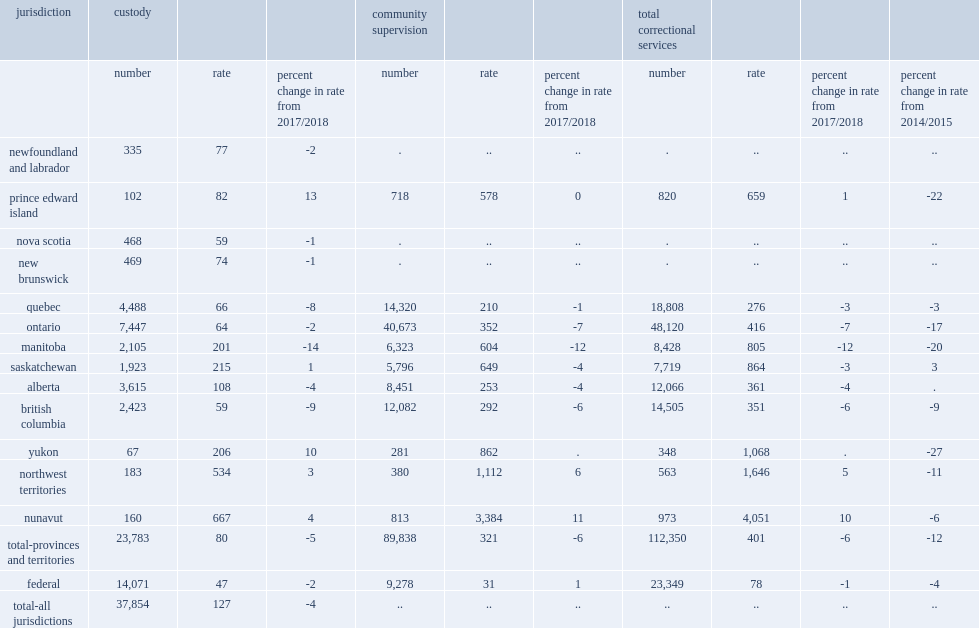In 2018/2019, what is the rate of custody of the national incarceration population? 127.0. In 2018/2019, the national incarceration rate of custody was 127 adults per 100,000 population, how much percentage below the rate from the previous year? 4. How many adults of average in provincial/territorial and federal custody per day in 2018/2019? 37854.0. How many adults were in provincial/territorial custody in 2018/2019? 23783.0. What is the rate of adults were in provincial/territorial custody in 2018/2019? 80.0. How many adults were in federal custody in 2018/2019? 14071.0. What is the rate of adults were in federal custody in 2018/2019? 47.0. Meanwhile, how much rates increased in prince edward island in 2018/2019? 13.0. Meanwhile, how much rates increased in yukon in 2018/2019? 10.0. Meanwhile, how much rates increased in nunavut in 2018/2019? 4.0. Meanwhile, how much rates increased in northwest territories in 2018/2019? 3.0. Meanwhile, how much rates increased in saskatchewan in 2018/2019? 1.0. In 2018/2019,what is the rate of adult provincial/territorial incarceration in saskatchewan ? 215.0. In 2018/2019,what is the rate of adult provincial/territorial incarceration in manitoba ? 201.0. In 2018/2019,what is the rate of adult provincial/territorial incarceration in alberta ? 108.0. In 2018/2019,what is the rate of adult provincial/territorial incarceration in prince edward island ? 82.0. 